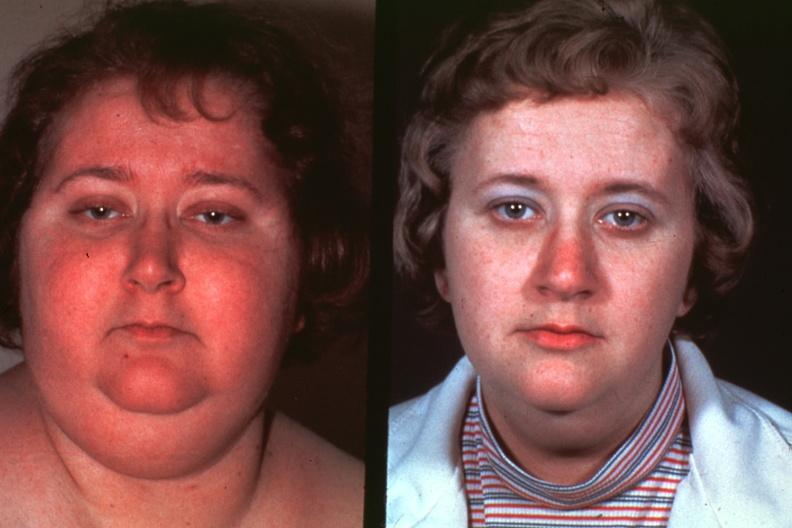when does this image show photos of lady before disease and?
Answer the question using a single word or phrase. After excellent 